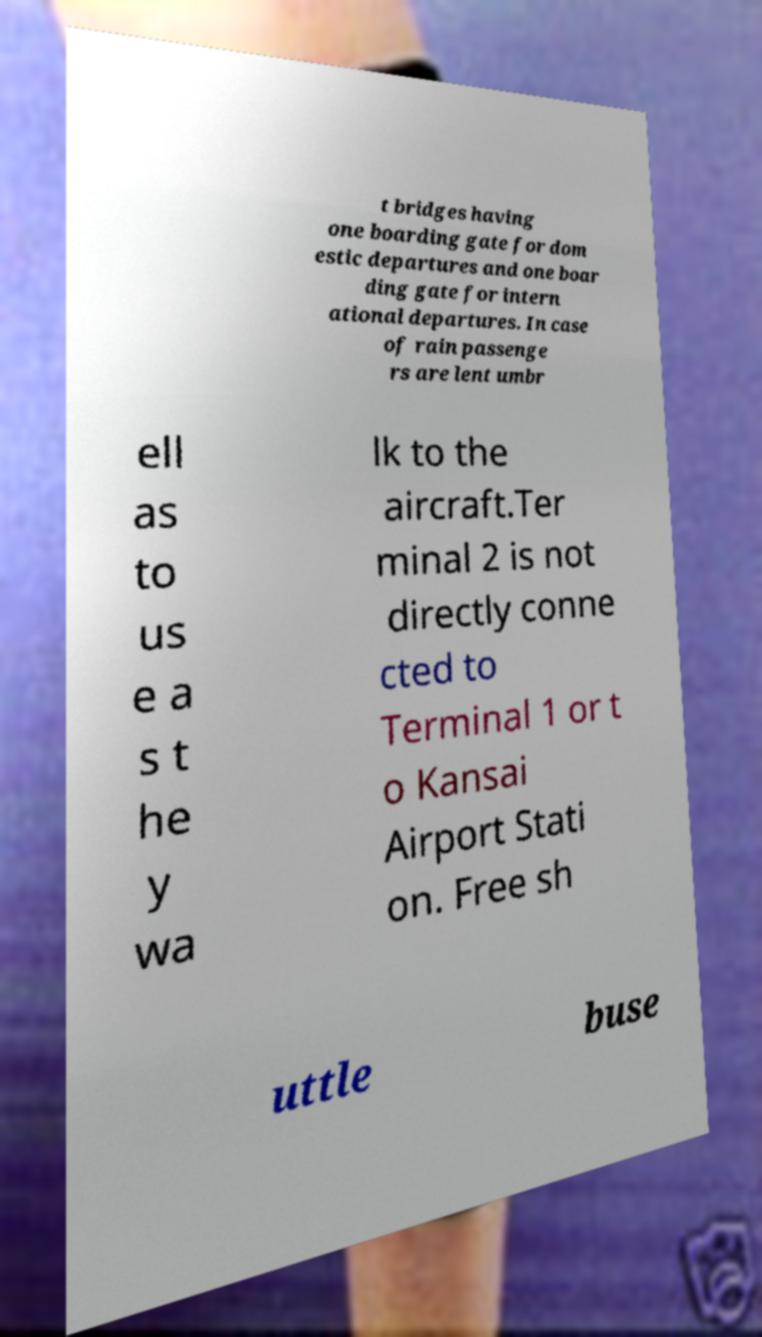What messages or text are displayed in this image? I need them in a readable, typed format. t bridges having one boarding gate for dom estic departures and one boar ding gate for intern ational departures. In case of rain passenge rs are lent umbr ell as to us e a s t he y wa lk to the aircraft.Ter minal 2 is not directly conne cted to Terminal 1 or t o Kansai Airport Stati on. Free sh uttle buse 